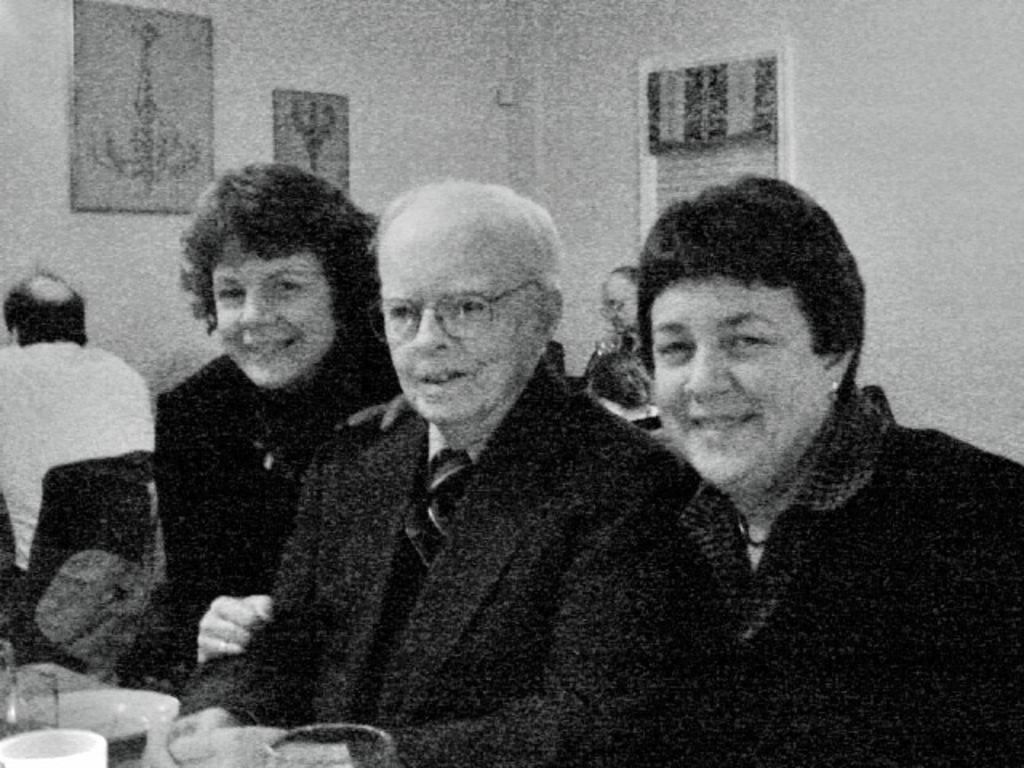Could you give a brief overview of what you see in this image? In this image we can see persons smiling and they are sitting in front of the table. On the table we can see the bowls and glasses. In the background we can see the frames attached to the wall. 